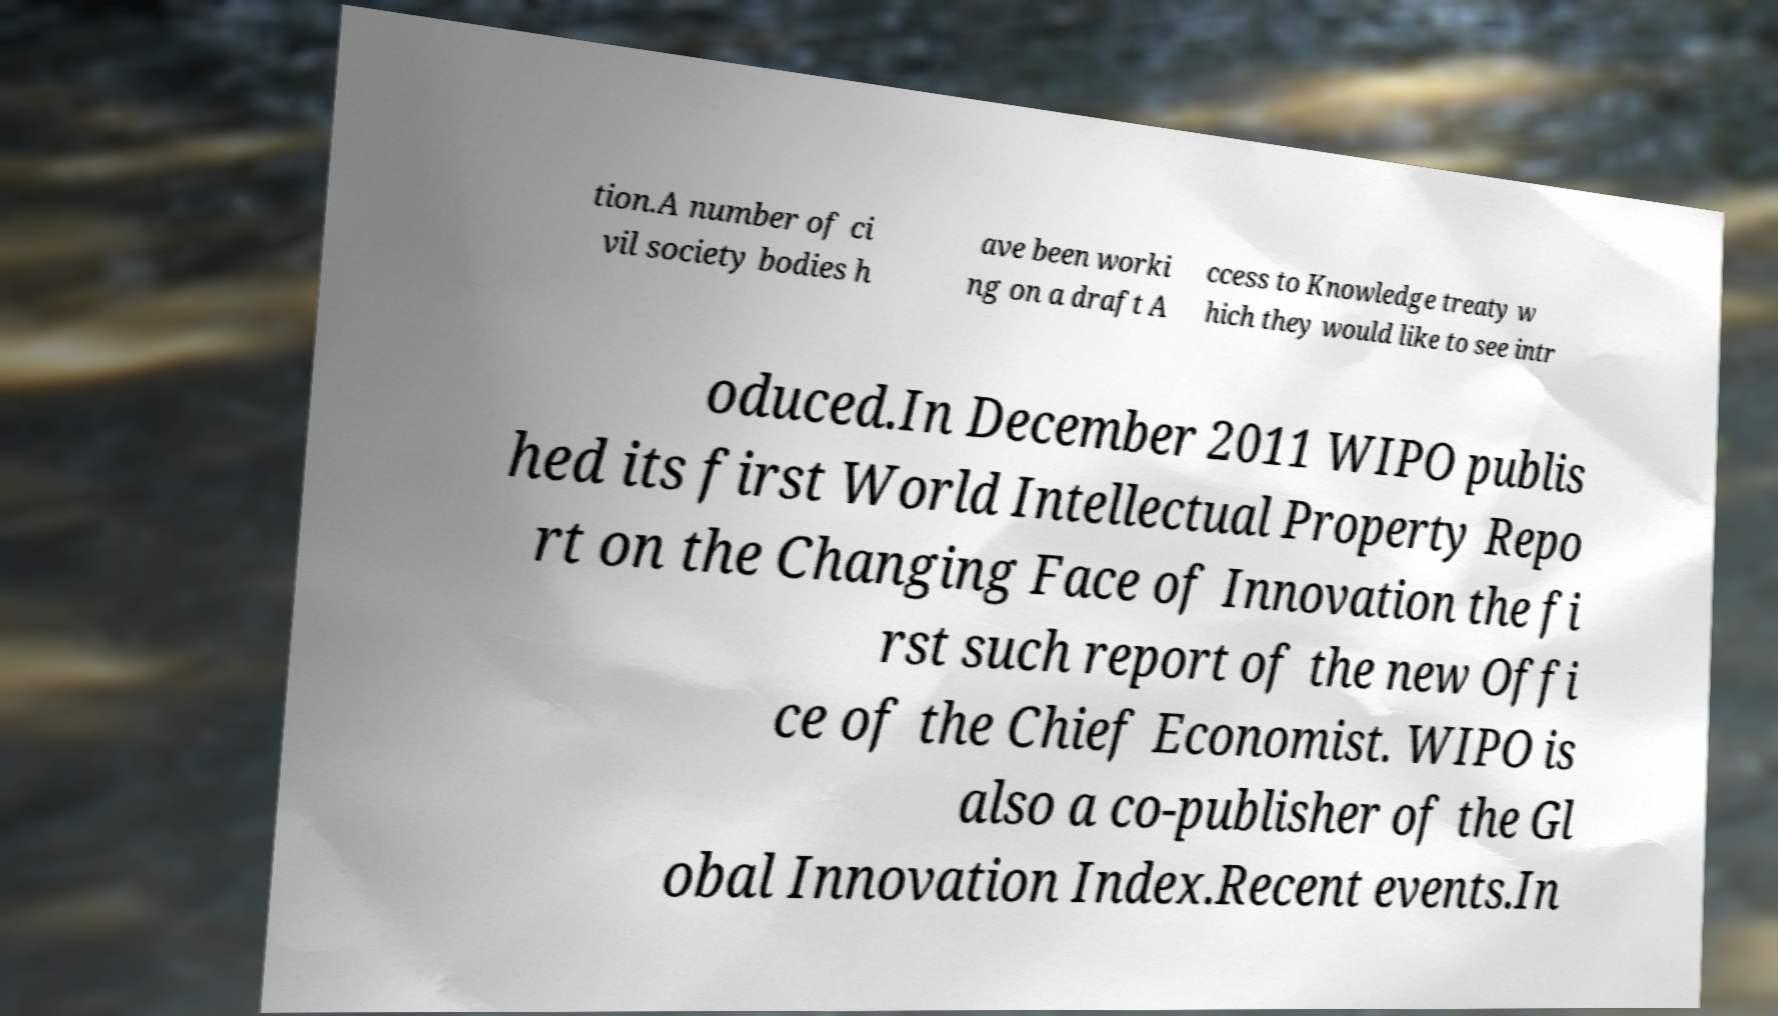Please identify and transcribe the text found in this image. tion.A number of ci vil society bodies h ave been worki ng on a draft A ccess to Knowledge treaty w hich they would like to see intr oduced.In December 2011 WIPO publis hed its first World Intellectual Property Repo rt on the Changing Face of Innovation the fi rst such report of the new Offi ce of the Chief Economist. WIPO is also a co-publisher of the Gl obal Innovation Index.Recent events.In 